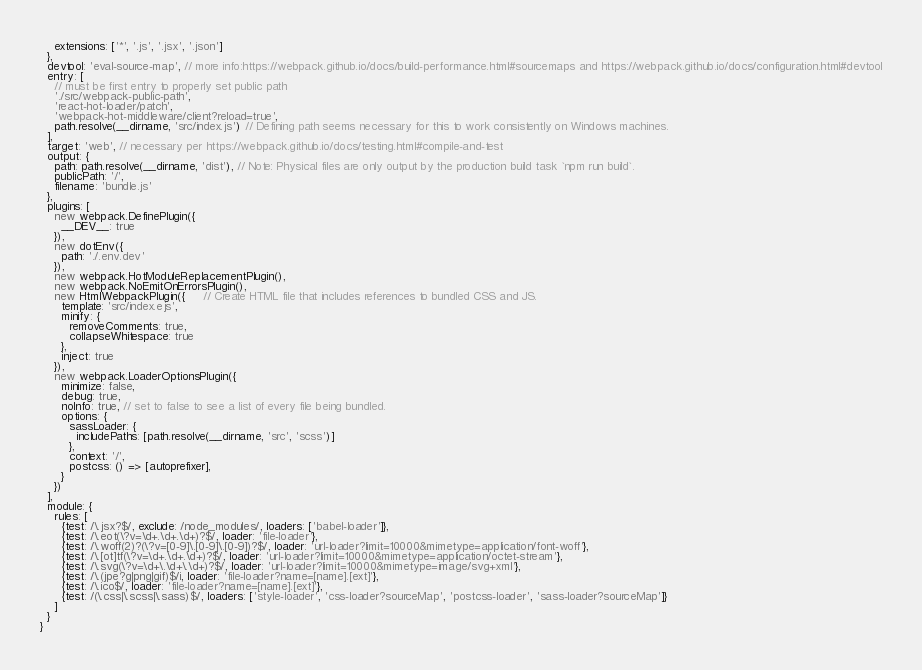Convert code to text. <code><loc_0><loc_0><loc_500><loc_500><_JavaScript_>    extensions: ['*', '.js', '.jsx', '.json']
  },
  devtool: 'eval-source-map', // more info:https://webpack.github.io/docs/build-performance.html#sourcemaps and https://webpack.github.io/docs/configuration.html#devtool
  entry: [
    // must be first entry to properly set public path
    './src/webpack-public-path',
    'react-hot-loader/patch',
    'webpack-hot-middleware/client?reload=true',
    path.resolve(__dirname, 'src/index.js') // Defining path seems necessary for this to work consistently on Windows machines.
  ],
  target: 'web', // necessary per https://webpack.github.io/docs/testing.html#compile-and-test
  output: {
    path: path.resolve(__dirname, 'dist'), // Note: Physical files are only output by the production build task `npm run build`.
    publicPath: '/',
    filename: 'bundle.js'
  },
  plugins: [
    new webpack.DefinePlugin({
      __DEV__: true
    }),
    new dotEnv({
      path: './.env.dev'
    }),
    new webpack.HotModuleReplacementPlugin(),
    new webpack.NoEmitOnErrorsPlugin(),
    new HtmlWebpackPlugin({     // Create HTML file that includes references to bundled CSS and JS.
      template: 'src/index.ejs',
      minify: {
        removeComments: true,
        collapseWhitespace: true
      },
      inject: true
    }),
    new webpack.LoaderOptionsPlugin({
      minimize: false,
      debug: true,
      noInfo: true, // set to false to see a list of every file being bundled.
      options: {
        sassLoader: {
          includePaths: [path.resolve(__dirname, 'src', 'scss')]
        },
        context: '/',
        postcss: () => [autoprefixer],
      }
    })
  ],
  module: {
    rules: [
      {test: /\.jsx?$/, exclude: /node_modules/, loaders: ['babel-loader']},
      {test: /\.eot(\?v=\d+.\d+.\d+)?$/, loader: 'file-loader'},
      {test: /\.woff(2)?(\?v=[0-9]\.[0-9]\.[0-9])?$/, loader: 'url-loader?limit=10000&mimetype=application/font-woff'},
      {test: /\.[ot]tf(\?v=\d+.\d+.\d+)?$/, loader: 'url-loader?limit=10000&mimetype=application/octet-stream'},
      {test: /\.svg(\?v=\d+\.\d+\.\d+)?$/, loader: 'url-loader?limit=10000&mimetype=image/svg+xml'},
      {test: /\.(jpe?g|png|gif)$/i, loader: 'file-loader?name=[name].[ext]'},
      {test: /\.ico$/, loader: 'file-loader?name=[name].[ext]'},
      {test: /(\.css|\.scss|\.sass)$/, loaders: ['style-loader', 'css-loader?sourceMap', 'postcss-loader', 'sass-loader?sourceMap']}
    ]
  }
}
</code> 